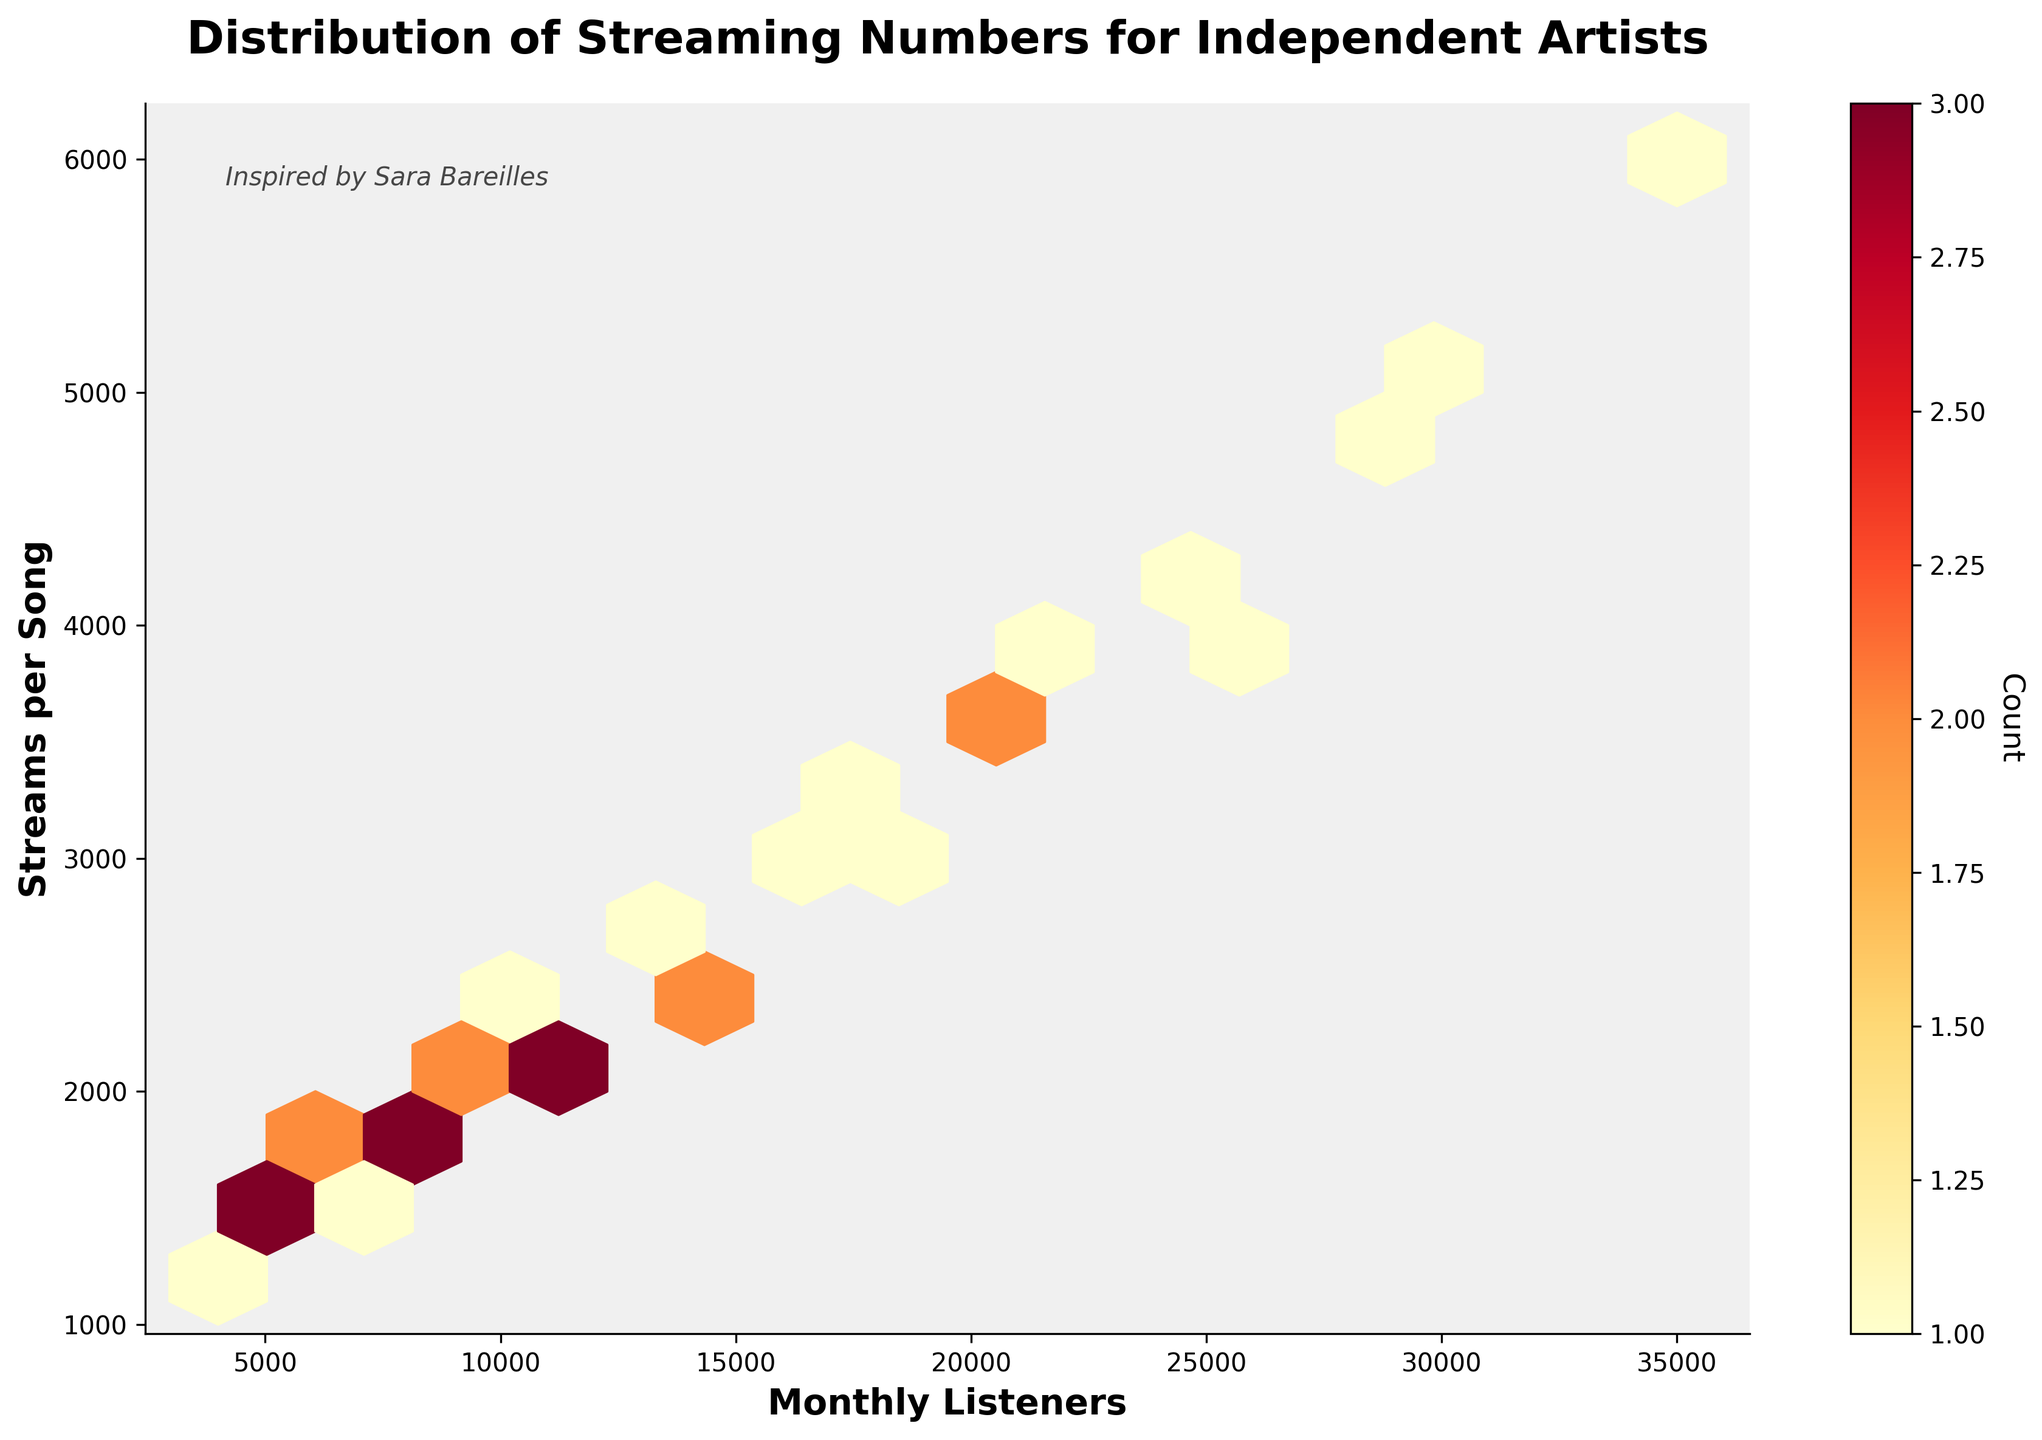What's the title of the figure? The title is displayed at the top of the plot in bold letters. It usually summarizes the main subject of the plot.
Answer: Distribution of Streaming Numbers for Independent Artists Which axis represents the monthly listeners? The x-axis represents the monthly listeners, as indicated by the label 'Monthly Listeners' below the axis.
Answer: x-axis What does the color intensity in the hexbin plot represent? The color intensity represents the count of data points in each hexagon. This is explained by the color bar on the right side of the plot.
Answer: Count of data points Which platform has the highest number of monthly listeners in the dataset? By visually inspecting the clusters of data points, the platform with the highest monthly listeners is the one with the most spread on the x-axis. SoundCloud appears to have the highest concentration in the upper range.
Answer: SoundCloud Which platform shows the highest stream per song in the dataset? By visually inspecting the clusters of data points, the platform with the highest streams per song is the one with the most spread on the y-axis. YouTube Music seems to have the highest concentration in the upper range.
Answer: YouTube Music What is the general trend between monthly listeners and streams per song? Observing the distribution of data points, there is a positive correlation where an increase in monthly listeners generally corresponds to an increase in streams per song.
Answer: Positive correlation Are there any outliers evident in the plot, and where are they located? Outliers are data points that lie outside the general cluster of hexagons. They can be observed on the edges of the plot far from the density clusters.
Answer: Yes, on the edges Is there a platform that tends to have lower monthly listeners but higher streams per song? By examining the hexbin distribution, Deezer seems to have data points with lower monthly listeners but relatively decent streams per song compared to other platforms.
Answer: Deezer How are the hexagons distributed for platforms like Spotify compared to Apple Music? By comparing the spread of hexagons, Spotify's points appear more spread out and lie at higher values on both axes, whereas Apple Music's points are less spread and a bit lower.
Answer: Spotify is more spread and higher What's the typical range of streams per song when monthly listeners are between 10,000 and 20,000? Within the range of 10,000 to 20,000 monthly listeners, streams per song typically range between 2,000 to 3,500. This can be observed from the concentration of hexagons in that range.
Answer: 2,000 to 3,500 